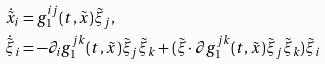Convert formula to latex. <formula><loc_0><loc_0><loc_500><loc_500>& \dot { \tilde { x } } _ { i } = g _ { 1 } ^ { i j } ( t , \tilde { x } ) \tilde { \xi } _ { j } , \\ & \dot { \tilde { \xi } } _ { i } = - \partial _ { i } g _ { 1 } ^ { j k } ( t , \tilde { x } ) \tilde { \xi } _ { j } \tilde { \xi } _ { k } + ( \tilde { \xi } \cdot \partial g _ { 1 } ^ { j k } ( t , \tilde { x } ) \tilde { \xi } _ { j } \tilde { \xi } _ { k } ) \tilde { \xi } _ { i }</formula> 